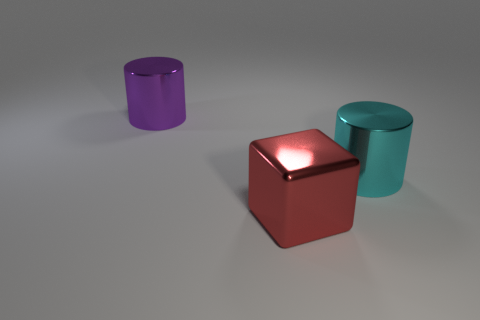Are there fewer purple cylinders that are right of the big purple object than purple matte cylinders?
Offer a very short reply. No. Are there any other things that are the same shape as the red thing?
Provide a short and direct response. No. What is the color of the other thing that is the same shape as the large cyan object?
Your answer should be compact. Purple. There is a metallic cylinder to the right of the purple metallic thing; does it have the same size as the large purple cylinder?
Offer a very short reply. Yes. Do the cyan object and the big thing that is to the left of the big red metal cube have the same material?
Ensure brevity in your answer.  Yes. Are there fewer big metallic cylinders that are on the right side of the red object than shiny objects to the right of the purple metal object?
Your answer should be compact. Yes. There is a large block that is made of the same material as the cyan object; what is its color?
Your answer should be compact. Red. There is a metallic cylinder that is on the right side of the shiny cube; is there a big purple shiny thing left of it?
Provide a short and direct response. Yes. There is a cylinder that is the same size as the cyan thing; what color is it?
Give a very brief answer. Purple. What number of things are purple cylinders or big red shiny things?
Give a very brief answer. 2. 